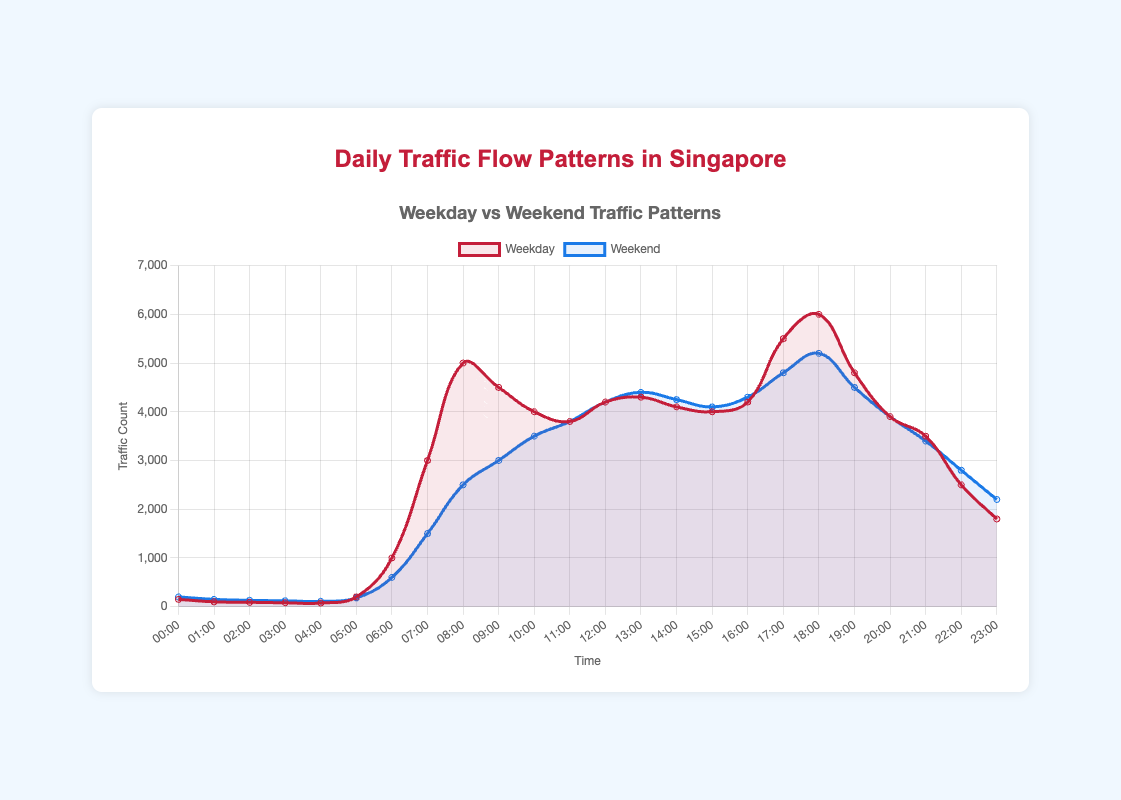What is the difference in traffic count between 08:00 and 20:00 on weekdays? According to the plot, the traffic count at 08:00 on weekdays is 5000, and at 20:00 it is 3900. The difference is 5000 - 3900 = 1100
Answer: 1100 At what times on weekends is the traffic count exactly 4200? The plot shows traffic counts that correspond to different times. The traffic count of 4200 occurs at 12:00 and 13:00 on weekends
Answer: 12:00 and 13:00 Which has a higher traffic count at 16:00, weekdays or weekends? According to the graph, the traffic count at 16:00 on weekdays is 4200, while on weekends, it is 4300. Therefore, weekends have a higher traffic count at this time
Answer: weekends What is the average traffic count between 00:00 to 05:00 on weekdays? The traffic counts at 00:00, 01:00, 02:00, 03:00, 04:00, and 05:00 are 150, 100, 90, 80, 75, and 200 respectively. The sum is 150 + 100 + 90 + 80 + 75 + 200 = 695. The average is 695/6 ≈ 116
Answer: 116 During which time period in the day do weekdays have the highest traffic flow? According to the plot, weekdays have the highest traffic count at 18:00 with a traffic count of 6000
Answer: 18:00 What is the combined traffic count for weekdays at 17:00 and 18:00? The traffic count at 17:00 is 5500 and at 18:00 is 6000. The combined traffic count is 5500 + 6000 = 11500
Answer: 11500 Describe the trend of traffic flow from 06:00 to 10:00 during weekends The traffic count rises steadily from 600 at 06:00, peaks at 3000 at 09:00, and then continues to rise up to 3500 at 10:00
Answer: Rising from 600 to 3500 How does the traffic at 07:00 on weekdays compare to the same time on weekends? At 07:00, the traffic count on weekdays is 3000 while on weekends it is 1500. Therefore, there is double the traffic on weekdays compared to weekends at 07:00
Answer: weekdays have twice the traffic What is the maximum traffic count observed over the entire time period on weekends? The plot indicates that the highest traffic count on weekends is 5200, observed at 18:00
Answer: 5200 Is traffic count generally higher in the morning or evening on weekdays? Comparing the morning (06:00-10:00) counts, which range from 1000 to 5000, with the evening (16:00-20:00) counts, which range from 4200 to 6000, it shows that traffic is generally higher in the evening
Answer: evening 